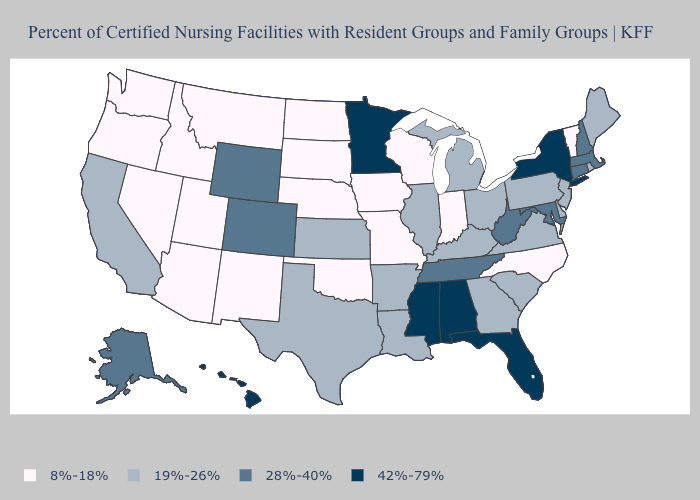What is the lowest value in the South?
Give a very brief answer. 8%-18%. Does Minnesota have the highest value in the MidWest?
Be succinct. Yes. Which states have the lowest value in the USA?
Quick response, please. Arizona, Idaho, Indiana, Iowa, Missouri, Montana, Nebraska, Nevada, New Mexico, North Carolina, North Dakota, Oklahoma, Oregon, South Dakota, Utah, Vermont, Washington, Wisconsin. Name the states that have a value in the range 19%-26%?
Short answer required. Arkansas, California, Delaware, Georgia, Illinois, Kansas, Kentucky, Louisiana, Maine, Michigan, New Jersey, Ohio, Pennsylvania, Rhode Island, South Carolina, Texas, Virginia. Which states hav the highest value in the Northeast?
Short answer required. New York. Name the states that have a value in the range 42%-79%?
Quick response, please. Alabama, Florida, Hawaii, Minnesota, Mississippi, New York. Is the legend a continuous bar?
Write a very short answer. No. Which states hav the highest value in the MidWest?
Keep it brief. Minnesota. Name the states that have a value in the range 8%-18%?
Short answer required. Arizona, Idaho, Indiana, Iowa, Missouri, Montana, Nebraska, Nevada, New Mexico, North Carolina, North Dakota, Oklahoma, Oregon, South Dakota, Utah, Vermont, Washington, Wisconsin. What is the lowest value in states that border Utah?
Keep it brief. 8%-18%. Which states have the highest value in the USA?
Quick response, please. Alabama, Florida, Hawaii, Minnesota, Mississippi, New York. Name the states that have a value in the range 19%-26%?
Write a very short answer. Arkansas, California, Delaware, Georgia, Illinois, Kansas, Kentucky, Louisiana, Maine, Michigan, New Jersey, Ohio, Pennsylvania, Rhode Island, South Carolina, Texas, Virginia. Does New Mexico have a lower value than North Carolina?
Be succinct. No. Name the states that have a value in the range 8%-18%?
Be succinct. Arizona, Idaho, Indiana, Iowa, Missouri, Montana, Nebraska, Nevada, New Mexico, North Carolina, North Dakota, Oklahoma, Oregon, South Dakota, Utah, Vermont, Washington, Wisconsin. 